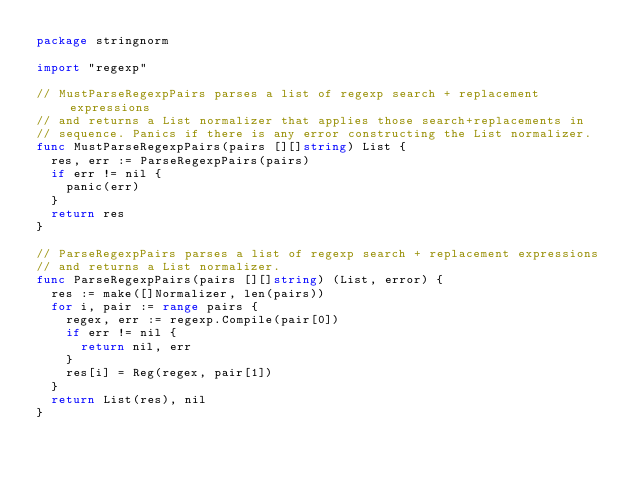Convert code to text. <code><loc_0><loc_0><loc_500><loc_500><_Go_>package stringnorm

import "regexp"

// MustParseRegexpPairs parses a list of regexp search + replacement expressions
// and returns a List normalizer that applies those search+replacements in
// sequence. Panics if there is any error constructing the List normalizer.
func MustParseRegexpPairs(pairs [][]string) List {
	res, err := ParseRegexpPairs(pairs)
	if err != nil {
		panic(err)
	}
	return res
}

// ParseRegexpPairs parses a list of regexp search + replacement expressions
// and returns a List normalizer.
func ParseRegexpPairs(pairs [][]string) (List, error) {
	res := make([]Normalizer, len(pairs))
	for i, pair := range pairs {
		regex, err := regexp.Compile(pair[0])
		if err != nil {
			return nil, err
		}
		res[i] = Reg(regex, pair[1])
	}
	return List(res), nil
}
</code> 